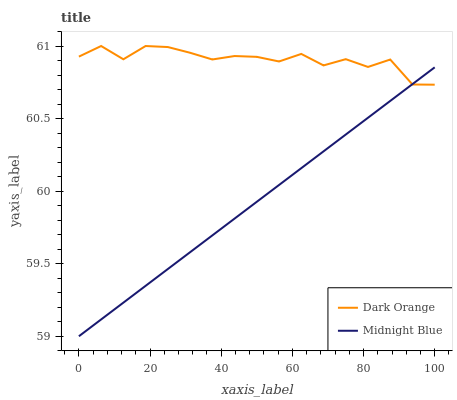Does Midnight Blue have the minimum area under the curve?
Answer yes or no. Yes. Does Dark Orange have the maximum area under the curve?
Answer yes or no. Yes. Does Midnight Blue have the maximum area under the curve?
Answer yes or no. No. Is Midnight Blue the smoothest?
Answer yes or no. Yes. Is Dark Orange the roughest?
Answer yes or no. Yes. Is Midnight Blue the roughest?
Answer yes or no. No. Does Midnight Blue have the lowest value?
Answer yes or no. Yes. Does Dark Orange have the highest value?
Answer yes or no. Yes. Does Midnight Blue have the highest value?
Answer yes or no. No. Does Dark Orange intersect Midnight Blue?
Answer yes or no. Yes. Is Dark Orange less than Midnight Blue?
Answer yes or no. No. Is Dark Orange greater than Midnight Blue?
Answer yes or no. No. 